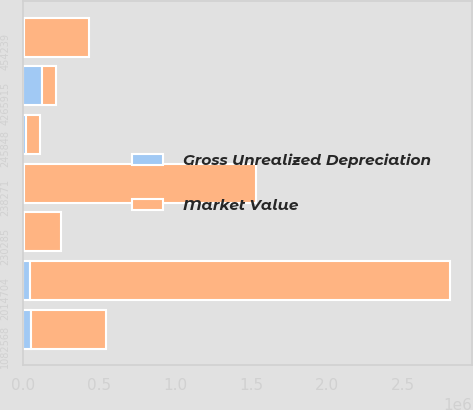Convert chart. <chart><loc_0><loc_0><loc_500><loc_500><stacked_bar_chart><ecel><fcel>454239<fcel>2014704<fcel>1082568<fcel>245848<fcel>230285<fcel>238271<fcel>4265915<nl><fcel>Gross Unrealized Depreciation<fcel>2558<fcel>45148<fcel>51300<fcel>16957<fcel>2746<fcel>2129<fcel>120838<nl><fcel>Market Value<fcel>427513<fcel>2.76498e+06<fcel>492216<fcel>91094<fcel>245300<fcel>1.52783e+06<fcel>91094<nl></chart> 